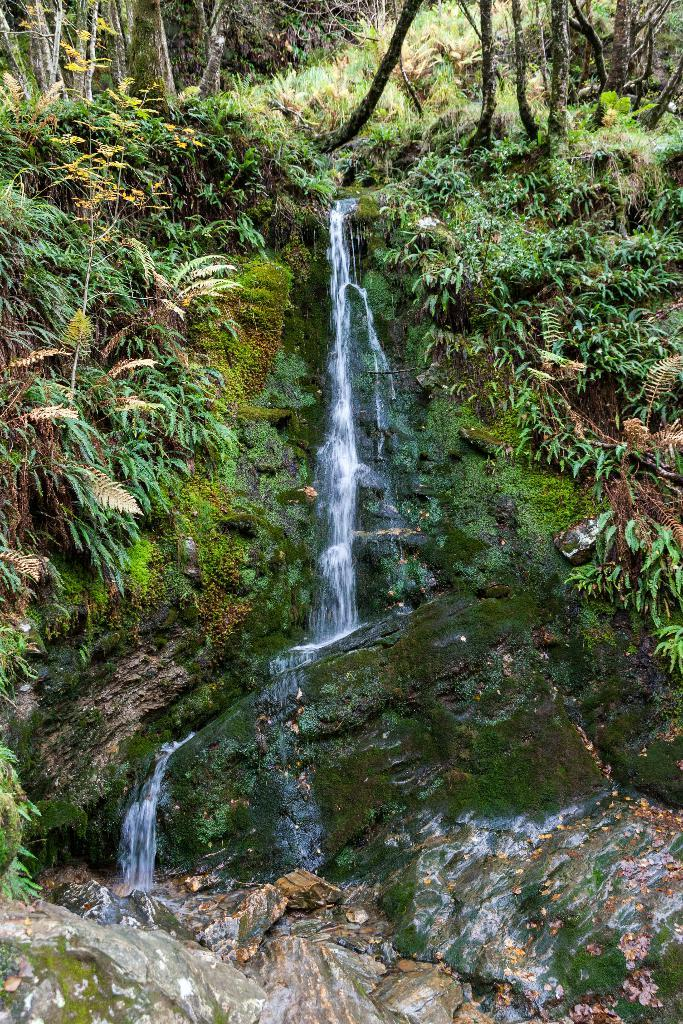What natural feature is the main subject of the picture? There is a waterfall in the picture. What type of geological formation can be seen in the picture? Rocks are present in the picture. What type of plant material is visible in the picture? Dry leaves are visible in the picture. What type of vegetation is in the picture? Trees are in the picture. What type of shirt is hanging on the tree in the picture? There is no shirt hanging on a tree in the picture; only natural elements are present. 